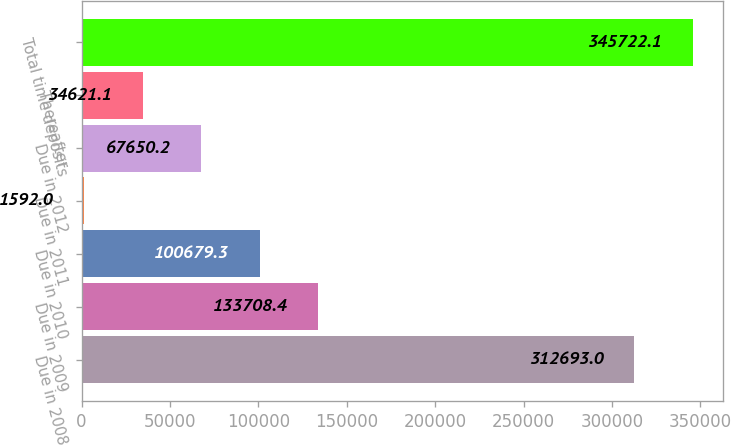Convert chart to OTSL. <chart><loc_0><loc_0><loc_500><loc_500><bar_chart><fcel>Due in 2008<fcel>Due in 2009<fcel>Due in 2010<fcel>Due in 2011<fcel>Due in 2012<fcel>Thereafter<fcel>Total time deposits<nl><fcel>312693<fcel>133708<fcel>100679<fcel>1592<fcel>67650.2<fcel>34621.1<fcel>345722<nl></chart> 